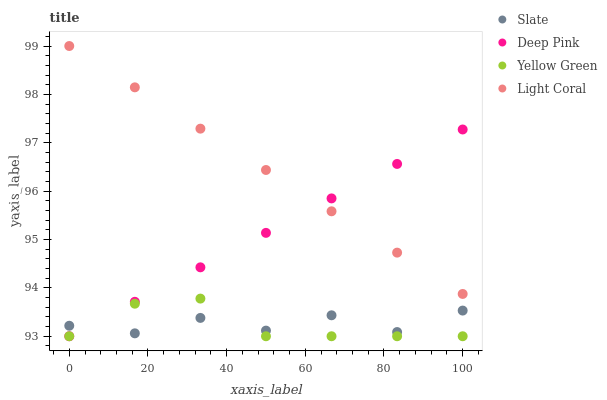Does Slate have the minimum area under the curve?
Answer yes or no. Yes. Does Light Coral have the maximum area under the curve?
Answer yes or no. Yes. Does Deep Pink have the minimum area under the curve?
Answer yes or no. No. Does Deep Pink have the maximum area under the curve?
Answer yes or no. No. Is Deep Pink the smoothest?
Answer yes or no. Yes. Is Slate the roughest?
Answer yes or no. Yes. Is Slate the smoothest?
Answer yes or no. No. Is Deep Pink the roughest?
Answer yes or no. No. Does Deep Pink have the lowest value?
Answer yes or no. Yes. Does Slate have the lowest value?
Answer yes or no. No. Does Light Coral have the highest value?
Answer yes or no. Yes. Does Deep Pink have the highest value?
Answer yes or no. No. Is Yellow Green less than Light Coral?
Answer yes or no. Yes. Is Light Coral greater than Yellow Green?
Answer yes or no. Yes. Does Deep Pink intersect Yellow Green?
Answer yes or no. Yes. Is Deep Pink less than Yellow Green?
Answer yes or no. No. Is Deep Pink greater than Yellow Green?
Answer yes or no. No. Does Yellow Green intersect Light Coral?
Answer yes or no. No. 